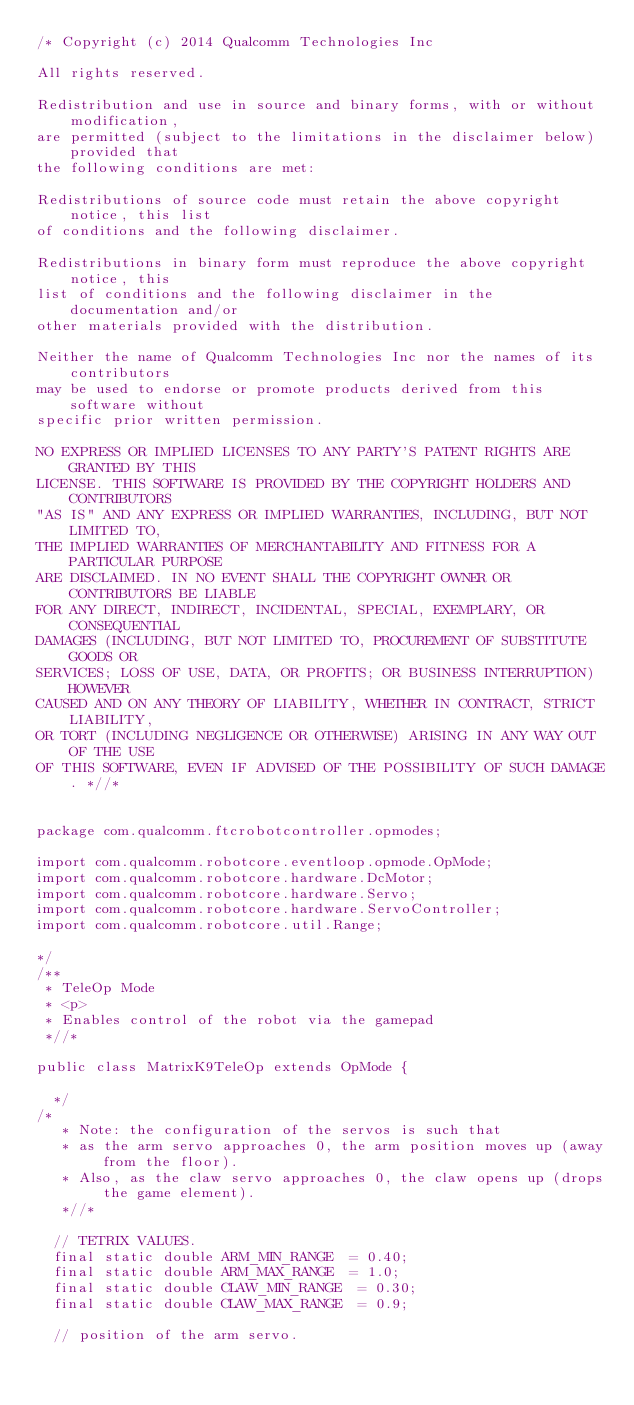Convert code to text. <code><loc_0><loc_0><loc_500><loc_500><_Java_>/* Copyright (c) 2014 Qualcomm Technologies Inc

All rights reserved.

Redistribution and use in source and binary forms, with or without modification,
are permitted (subject to the limitations in the disclaimer below) provided that
the following conditions are met:

Redistributions of source code must retain the above copyright notice, this list
of conditions and the following disclaimer.

Redistributions in binary form must reproduce the above copyright notice, this
list of conditions and the following disclaimer in the documentation and/or
other materials provided with the distribution.

Neither the name of Qualcomm Technologies Inc nor the names of its contributors
may be used to endorse or promote products derived from this software without
specific prior written permission.

NO EXPRESS OR IMPLIED LICENSES TO ANY PARTY'S PATENT RIGHTS ARE GRANTED BY THIS
LICENSE. THIS SOFTWARE IS PROVIDED BY THE COPYRIGHT HOLDERS AND CONTRIBUTORS
"AS IS" AND ANY EXPRESS OR IMPLIED WARRANTIES, INCLUDING, BUT NOT LIMITED TO,
THE IMPLIED WARRANTIES OF MERCHANTABILITY AND FITNESS FOR A PARTICULAR PURPOSE
ARE DISCLAIMED. IN NO EVENT SHALL THE COPYRIGHT OWNER OR CONTRIBUTORS BE LIABLE
FOR ANY DIRECT, INDIRECT, INCIDENTAL, SPECIAL, EXEMPLARY, OR CONSEQUENTIAL
DAMAGES (INCLUDING, BUT NOT LIMITED TO, PROCUREMENT OF SUBSTITUTE GOODS OR
SERVICES; LOSS OF USE, DATA, OR PROFITS; OR BUSINESS INTERRUPTION) HOWEVER
CAUSED AND ON ANY THEORY OF LIABILITY, WHETHER IN CONTRACT, STRICT LIABILITY,
OR TORT (INCLUDING NEGLIGENCE OR OTHERWISE) ARISING IN ANY WAY OUT OF THE USE
OF THIS SOFTWARE, EVEN IF ADVISED OF THE POSSIBILITY OF SUCH DAMAGE. *//*


package com.qualcomm.ftcrobotcontroller.opmodes;

import com.qualcomm.robotcore.eventloop.opmode.OpMode;
import com.qualcomm.robotcore.hardware.DcMotor;
import com.qualcomm.robotcore.hardware.Servo;
import com.qualcomm.robotcore.hardware.ServoController;
import com.qualcomm.robotcore.util.Range;

*/
/**
 * TeleOp Mode
 * <p>
 * Enables control of the robot via the gamepad
 *//*

public class MatrixK9TeleOp extends OpMode {

	*/
/*
	 * Note: the configuration of the servos is such that
	 * as the arm servo approaches 0, the arm position moves up (away from the floor).
	 * Also, as the claw servo approaches 0, the claw opens up (drops the game element).
	 *//*

	// TETRIX VALUES.
	final static double ARM_MIN_RANGE  = 0.40;
	final static double ARM_MAX_RANGE  = 1.0;
	final static double CLAW_MIN_RANGE  = 0.30;
	final static double CLAW_MAX_RANGE  = 0.9;

	// position of the arm servo.</code> 